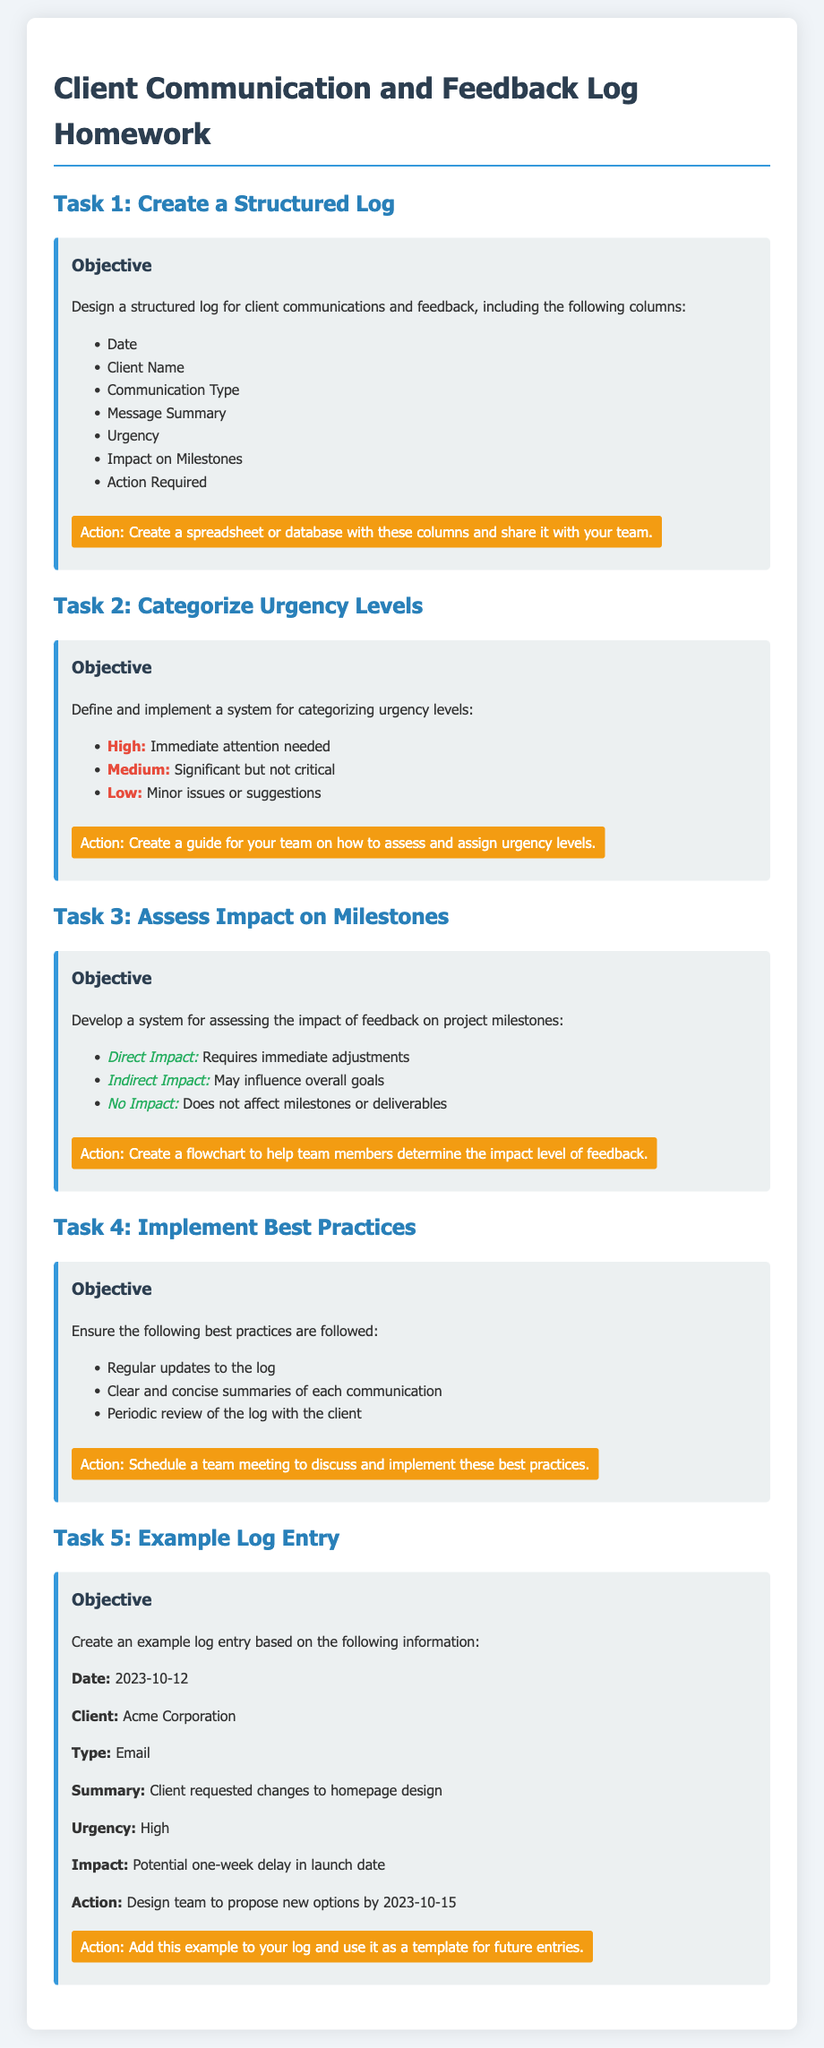What are the columns in the structured log? The document lists seven columns needed for the structured log including Date, Client Name, Communication Type, Message Summary, Urgency, Impact on Milestones, and Action Required.
Answer: Date, Client Name, Communication Type, Message Summary, Urgency, Impact on Milestones, Action Required What is the urgency level for immediate attention needed? The document defines urgency levels, and 'High' refers to immediate attention needed.
Answer: High When is the action for the design team to propose new options? The example log entry specifies a deadline for the design team to propose new options by 2023-10-15.
Answer: 2023-10-15 What type of communication was used in the example log entry? The example log entry indicates that the communication type was an email.
Answer: Email What is a recommended best practice for the log? The document lists several best practices, and one of them includes regular updates to the log.
Answer: Regular updates to the log What impact level is defined as requiring immediate adjustments? The document states that 'Direct Impact' requires immediate adjustments.
Answer: Direct Impact 